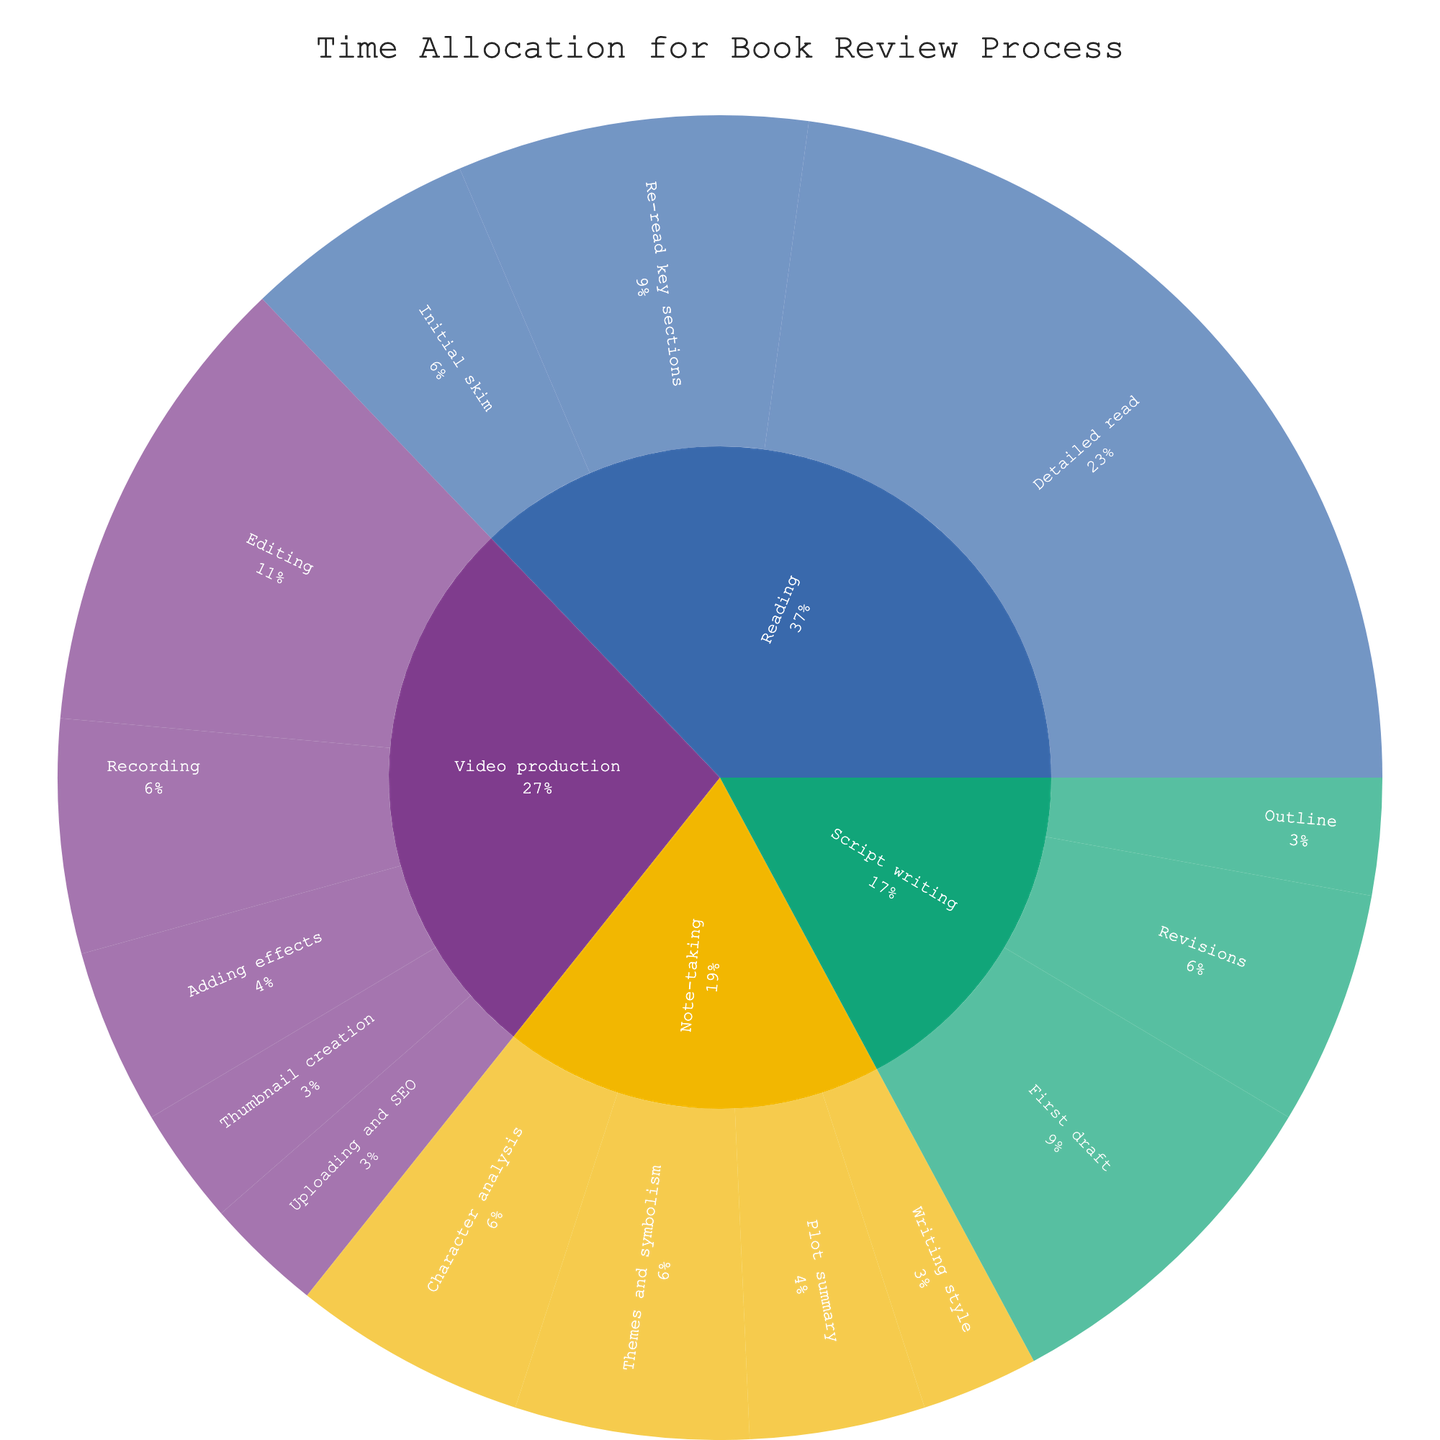What's the title of the figure? The title is usually displayed at the top of a figure. In this case, it clearly states the main subject.
Answer: Time Allocation for Book Review Process Which category takes the most time overall? The outer ring of the sunburst plot represented by the largest area indicates the category that consumes the most time. In this figure, 'Reading' occupies the largest segment.
Answer: Reading How much total time is spent on Script writing? Sum up the times for all subcategories under Script writing: Outline (1) + First draft (3) + Revisions (2).
Answer: 6 hours Which subcategory within Video production takes up the most time? Within the Video production segment, the largest portion corresponds to the subcategory with the highest time allocation. 'Editing' has the largest segment.
Answer: Editing What's the percentage of time spent on Note-taking across the whole process? Add up time spent on Note-taking, then divide by total time and multiply by 100. Total time is 32 (sum of all category times); Note-taking is 6.5. (6.5 / 32) × 100 ≈ 20.31%.
Answer: 20.31% Compare the time spent on Recording vs. Editing in Video production. Which is greater? Look at the sizes of the segments for Recording and Editing under Video production. Editing is larger than Recording.
Answer: Editing How much more time is spent on Detailed read compared to Initial skim? Subtract the time for Initial skim from Detailed read: 8 - 2.
Answer: 6 hours What's the total time spent on Note-taking for Character analysis and Themes and symbolism? Add the times for Character analysis and Themes and symbolism: 2 + 2.
Answer: 4 hours Which step in the entire process takes up exactly one hour? Identify the subcategories with a time allocation of 1 hour. Those are Writing style, Outline, Thumbnail creation, and Uploading and SEO.
Answer: Writing style, Outline, Thumbnail creation, Uploading and SEO Is more time spent Re-reading key sections or on the First draft of the script? Compare the times for Re-read key sections (3) and First draft (3).
Answer: Equal time is spent on both (3 hours each) 